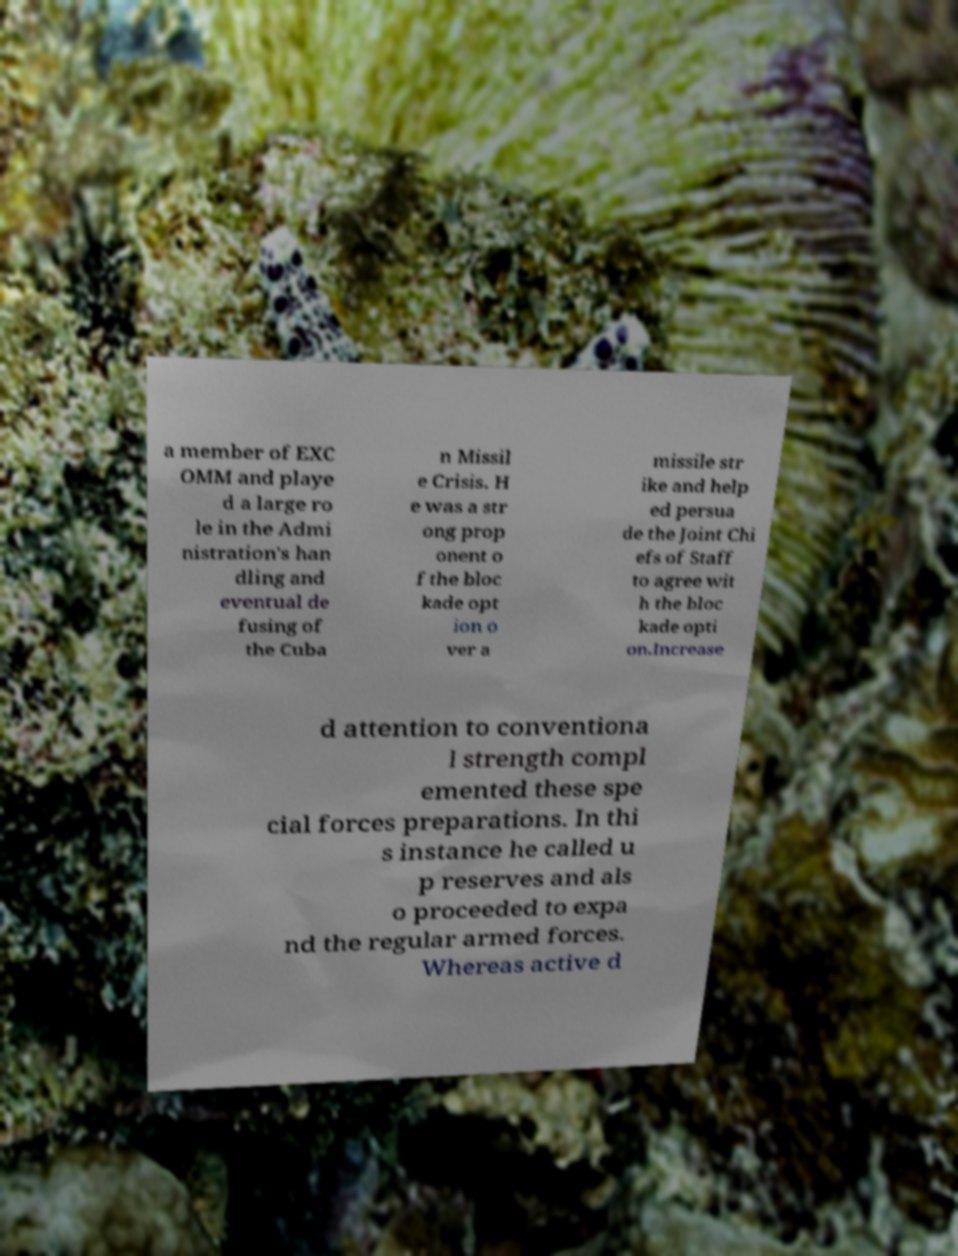I need the written content from this picture converted into text. Can you do that? a member of EXC OMM and playe d a large ro le in the Admi nistration's han dling and eventual de fusing of the Cuba n Missil e Crisis. H e was a str ong prop onent o f the bloc kade opt ion o ver a missile str ike and help ed persua de the Joint Chi efs of Staff to agree wit h the bloc kade opti on.Increase d attention to conventiona l strength compl emented these spe cial forces preparations. In thi s instance he called u p reserves and als o proceeded to expa nd the regular armed forces. Whereas active d 